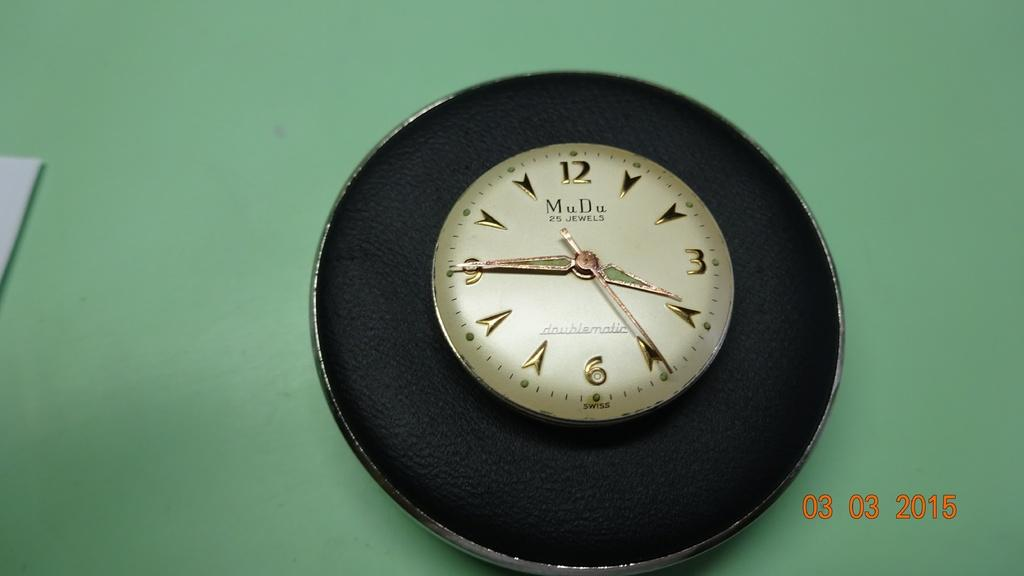<image>
Offer a succinct explanation of the picture presented. The face of a Mu Du 25 Jewels wrist watch is on a round, black display, in a photo taken on March 3, 2015. 